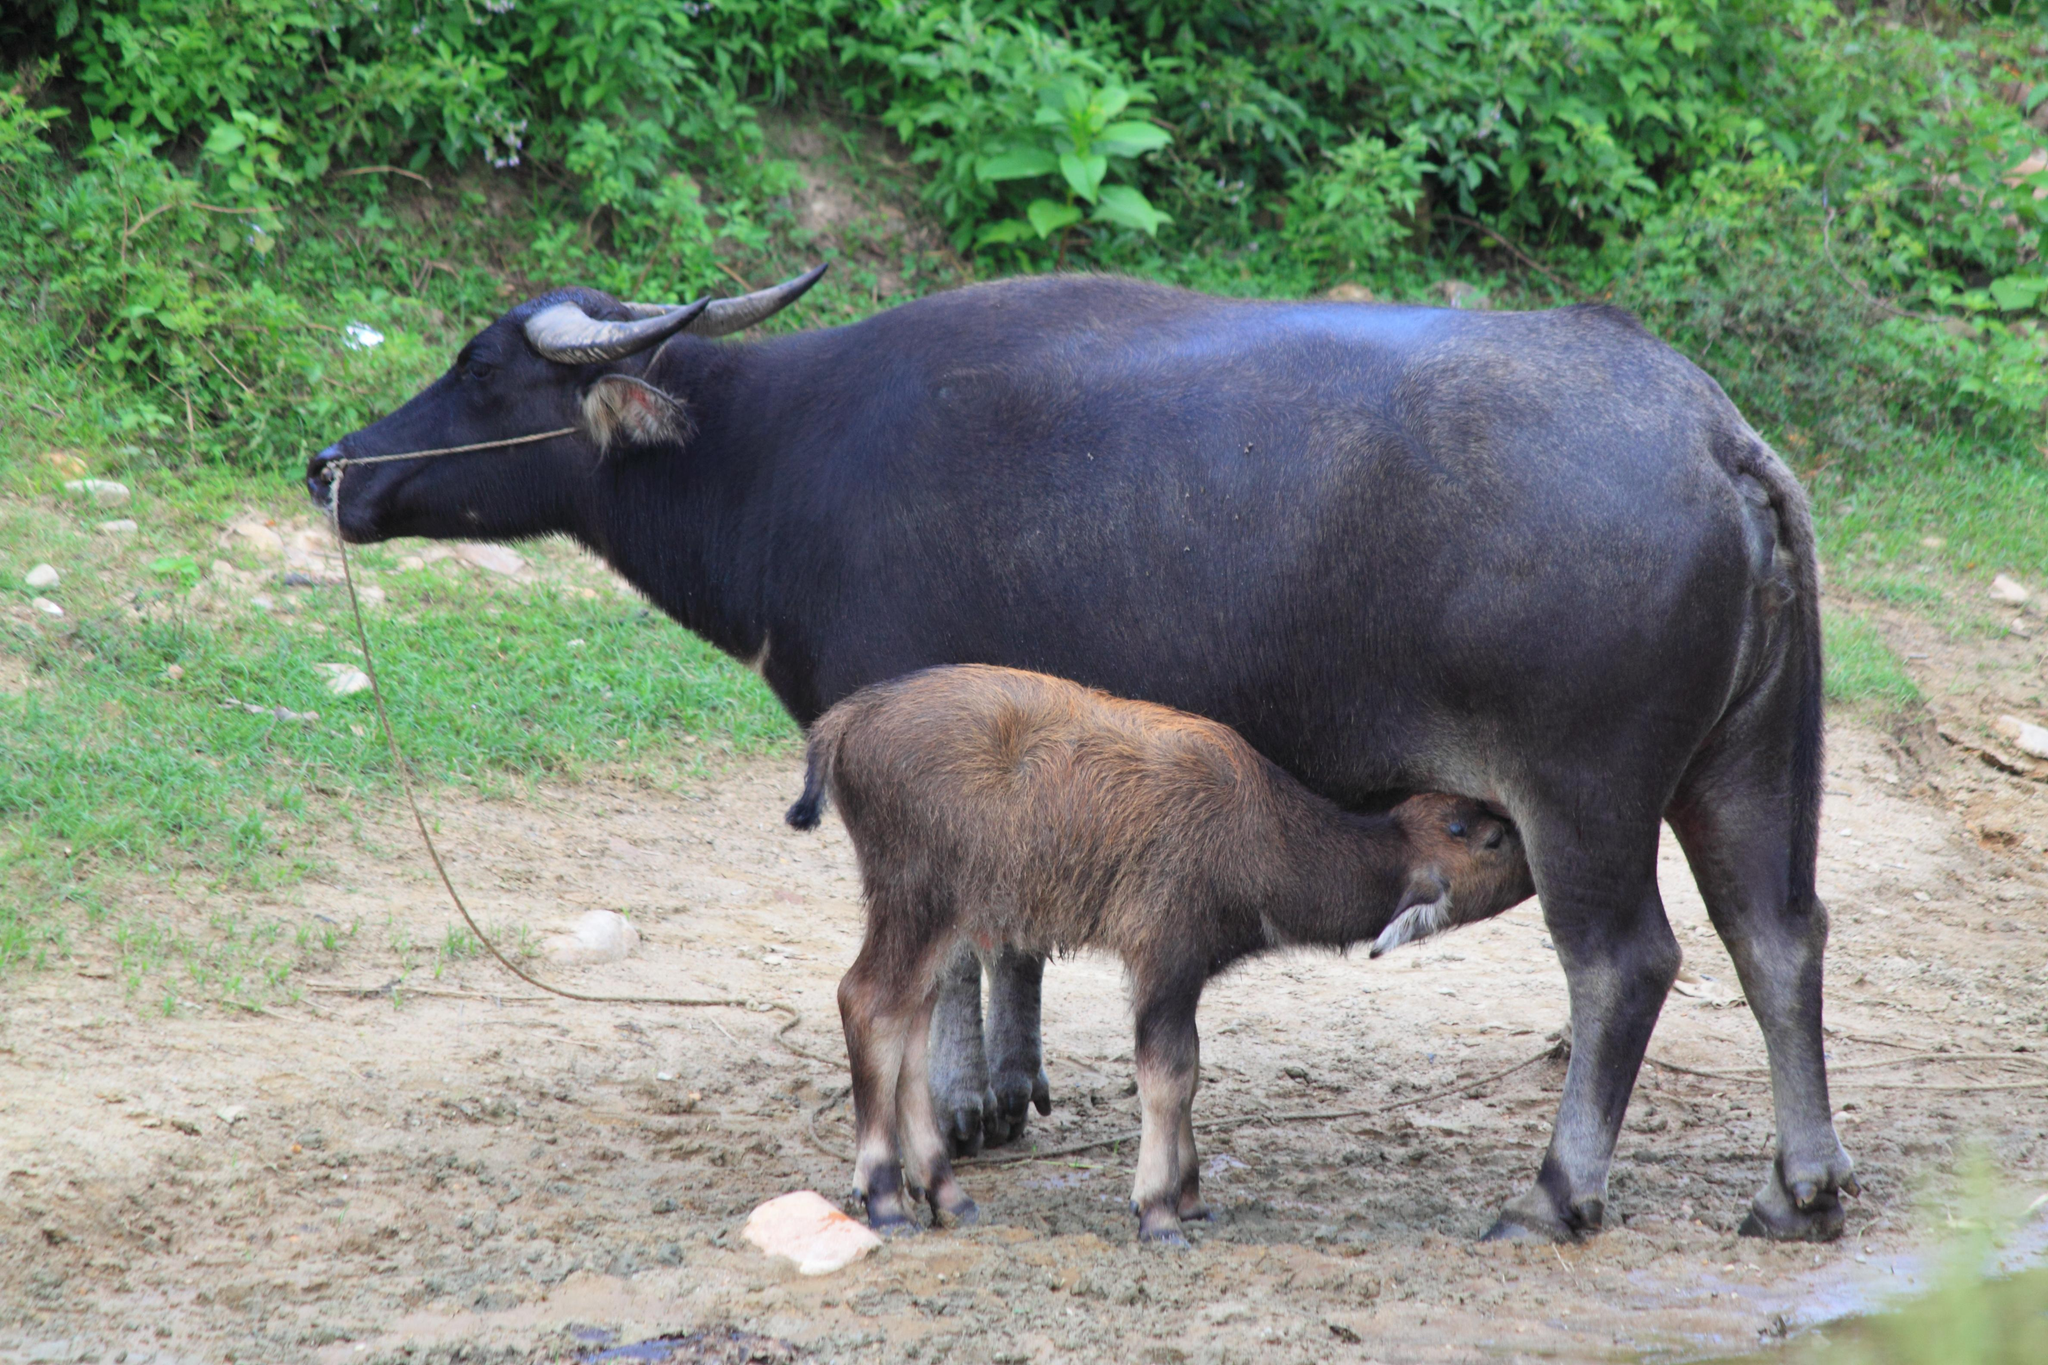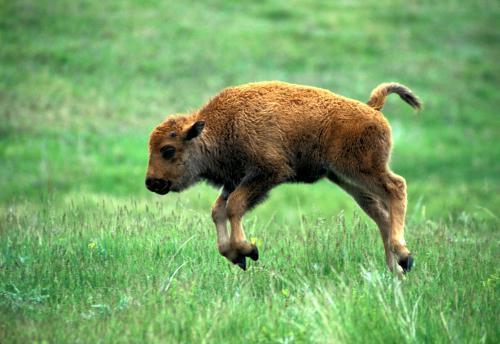The first image is the image on the left, the second image is the image on the right. Assess this claim about the two images: "There is water visible in at least one of the images.". Correct or not? Answer yes or no. No. The first image is the image on the left, the second image is the image on the right. Evaluate the accuracy of this statement regarding the images: "There is exactly one animal in the image on the right.". Is it true? Answer yes or no. Yes. 